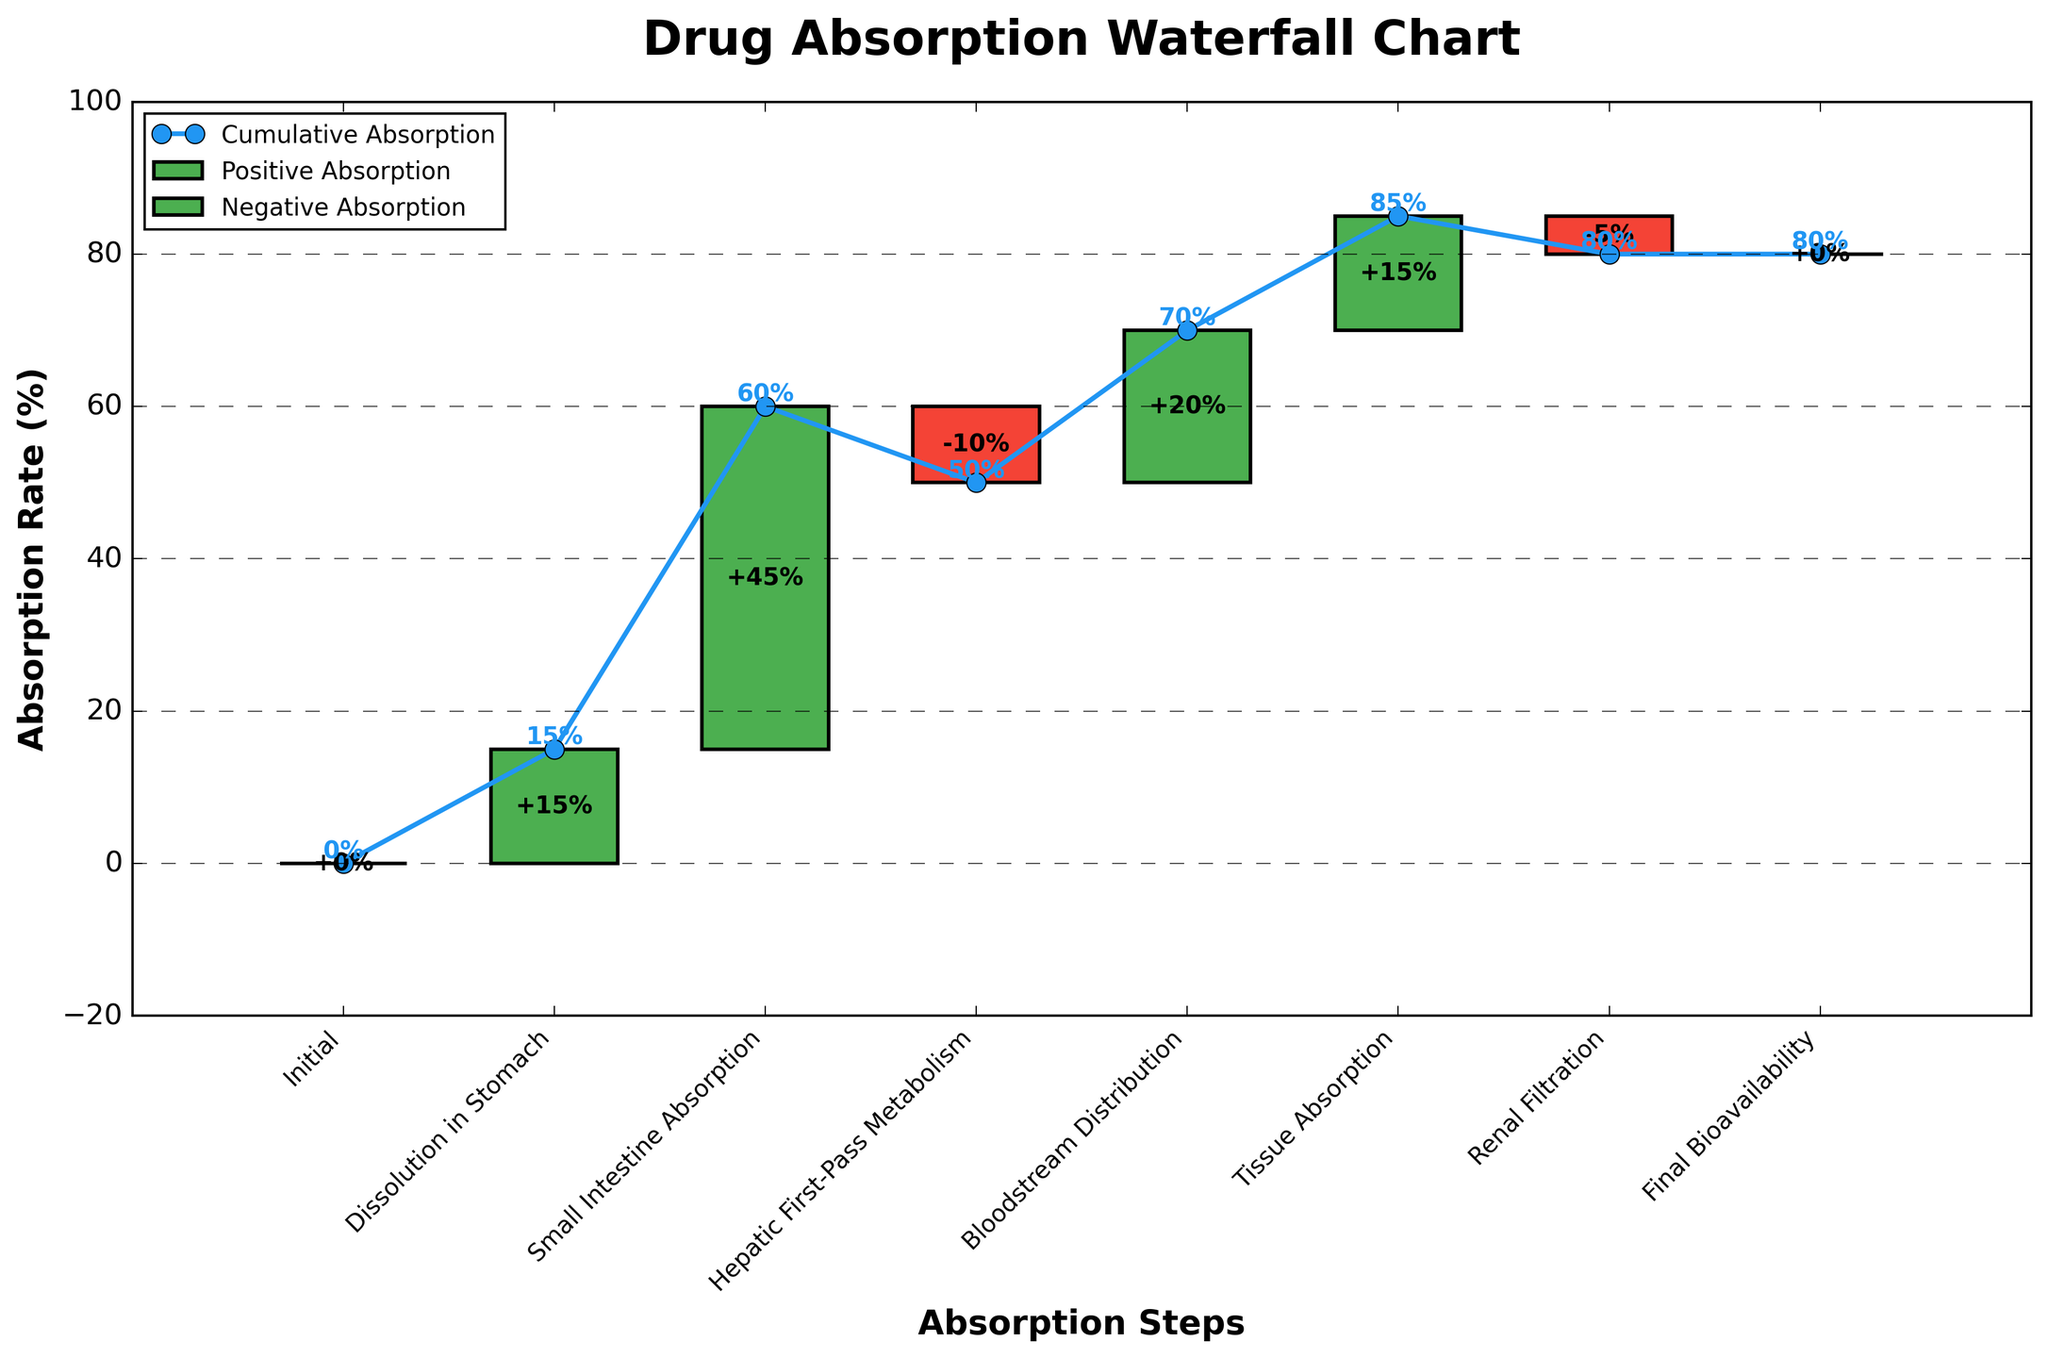What's the title of the chart? The title of the chart is located at the top of the figure. It provides a brief description of what the chart illustrates. The title reads "Drug Absorption Waterfall Chart".
Answer: Drug Absorption Waterfall Chart What is the absorption rate in the small intestine? The absorption rate for each step is marked by a vertical bar and annotated with a percentage. The step "Small Intestine Absorption" shows an absorption rate of 45%.
Answer: 45% How many steps show a decrease in absorption rate? The steps with a decrease in absorption rate are represented with red bars and negative values. The steps are "Hepatic First-Pass Metabolism" (-10%) and "Renal Filtration" (-5%). Hence, there are 2 steps with a decrease in absorption rate.
Answer: 2 What is the cumulative absorption after blood distribution? The cumulative absorption percentage is plotted as a line and marked at each step. After "Bloodstream Distribution", the cumulative absorption is shown as 70%.
Answer: 70% Which step has the highest positive absorption rate, and what is its value? By examining the green bars which indicate positive absorption rates, the highest value can be identified. "Small Intestine Absorption" has the highest absorption rate of 45%.
Answer: Small Intestine Absorption, 45% Calculate the total positive absorption rate. To find the total positive absorption rate, sum up all positive absorption rates: 15% (Dissolution in Stomach) + 45% (Small Intestine Absorption) + 20% (Bloodstream Distribution) + 15% (Tissue Absorption) = 95%.
Answer: 95% Compare the cumulative absorption rates between "Hepatic First-Pass Metabolism" and "Tissue Absorption". Which one is higher and by how much? "Hepatic First-Pass Metabolism" has a cumulative absorption of 50%, and "Tissue Absorption" has a cumulative absorption of 85%. The difference is 85% - 50% = 35%. Therefore, "Tissue Absorption" is higher by 35%.
Answer: Tissue Absorption is higher by 35% What is the net change in absorption rate due to hepatic first-pass metabolism and renal filtration combined? Both steps represent a decrease in absorption rate. The net change combines their negative values: (-10%) + (-5%) = -15%.
Answer: -15% What is the absorption rate difference between the first and last absorption steps? The absorption rates for the first and the last steps are "Dissolution in Stomach" with 15% and "Final Bioavailability" with 0%. The difference between them is 15% - 0% = 15%.
Answer: 15% At which step does the absorption rate first exceed 50%? The single-step absorption rates are sequentially accumulated. The cumulative absorption first exceeds 50% at the "Small Intestine Absorption" step, where it reaches 60%.
Answer: Small Intestine Absorption 